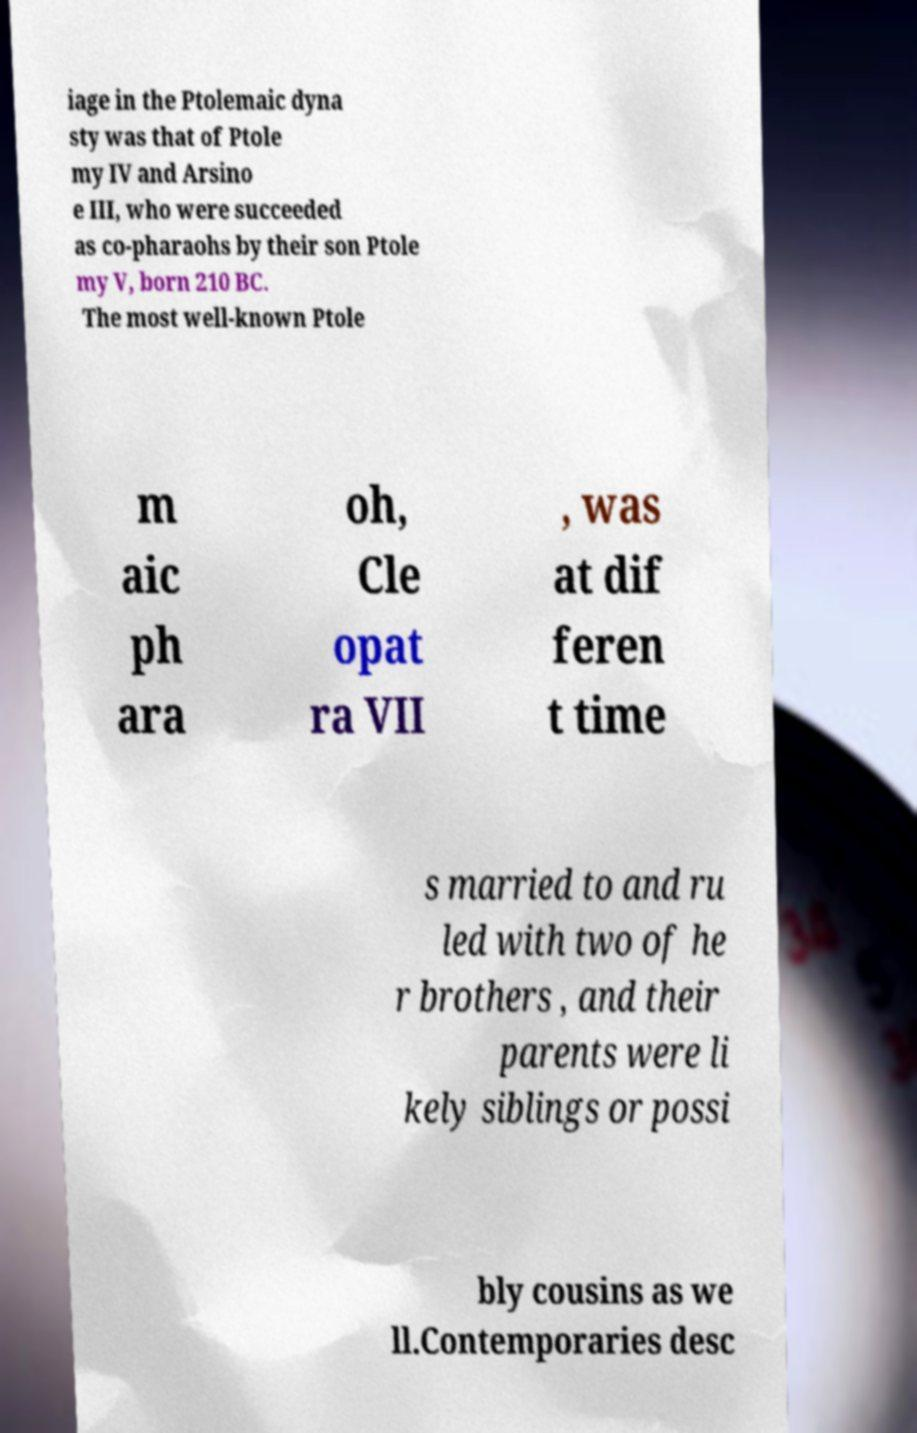Could you extract and type out the text from this image? iage in the Ptolemaic dyna sty was that of Ptole my IV and Arsino e III, who were succeeded as co-pharaohs by their son Ptole my V, born 210 BC. The most well-known Ptole m aic ph ara oh, Cle opat ra VII , was at dif feren t time s married to and ru led with two of he r brothers , and their parents were li kely siblings or possi bly cousins as we ll.Contemporaries desc 